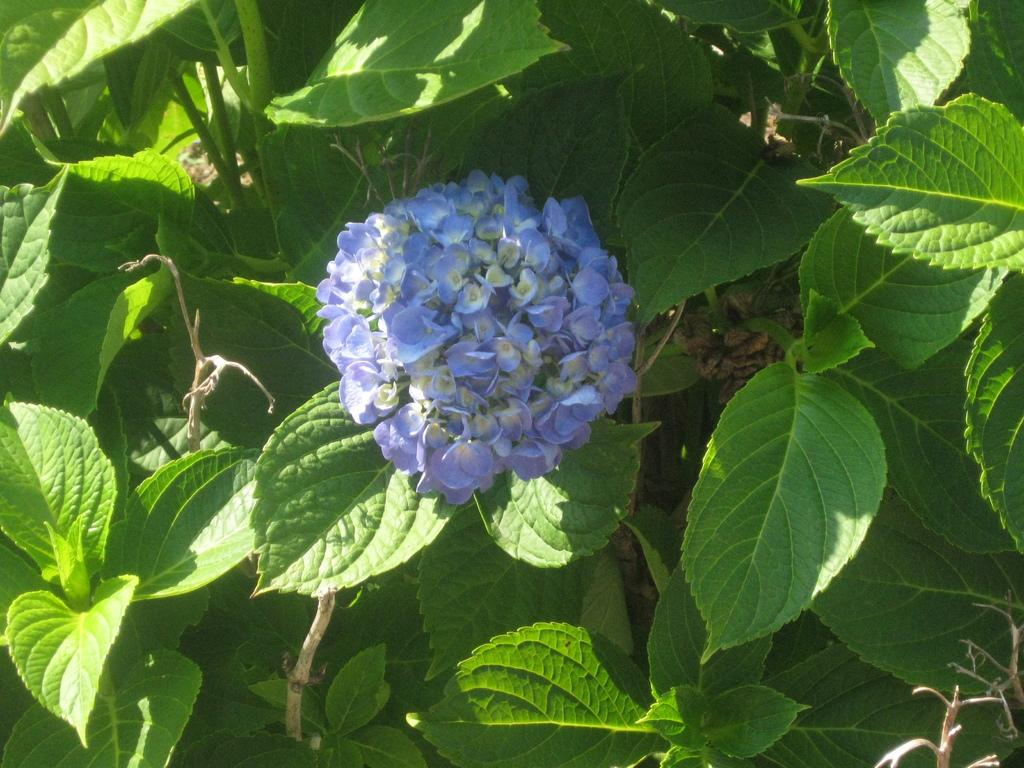What type of living organisms can be seen in the image? Plants can be seen in the image. What color are the flowers on the plants in the image? The flowers on the plants in the image are violet. What type of relation can be seen between the plants and the net in the image? There is no net present in the image, so there is no relation between the plants and a net. 